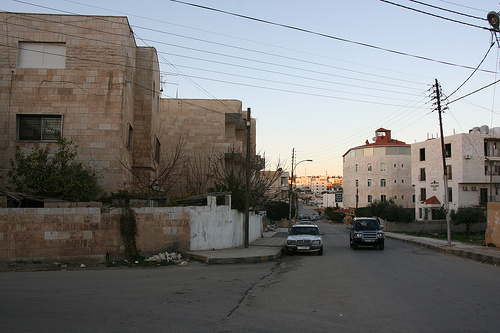<image>
Can you confirm if the wire is behind the suv? No. The wire is not behind the suv. From this viewpoint, the wire appears to be positioned elsewhere in the scene. 